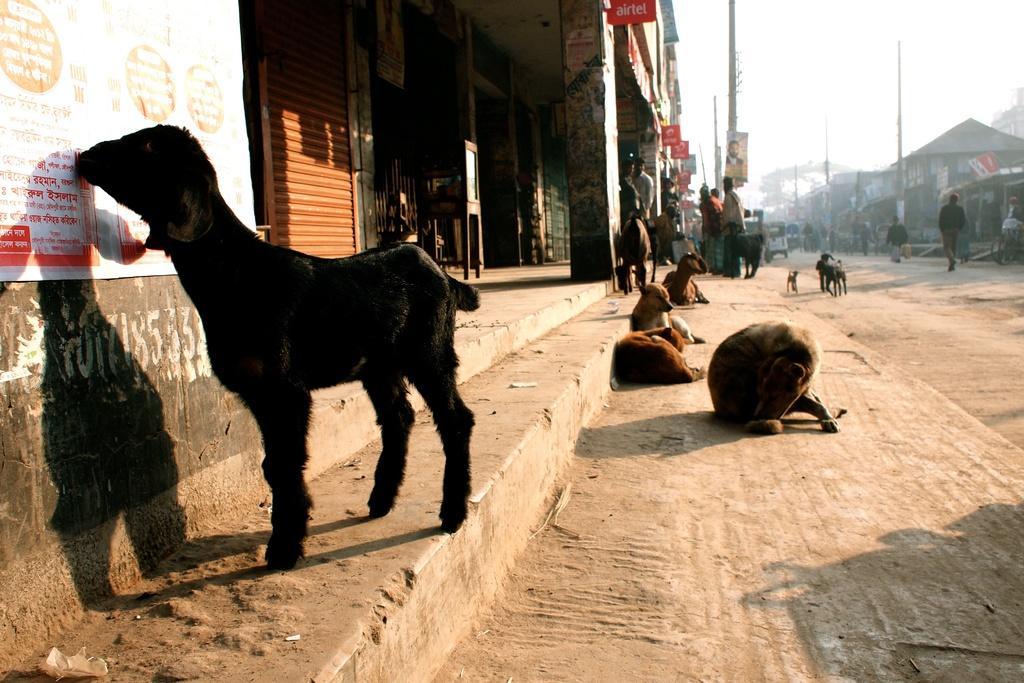In one or two sentences, can you explain what this image depicts? In this image I can see animals and people. In the background I can see poles, buildings and the sky. Here I can see boards attached to pillars and poles. 